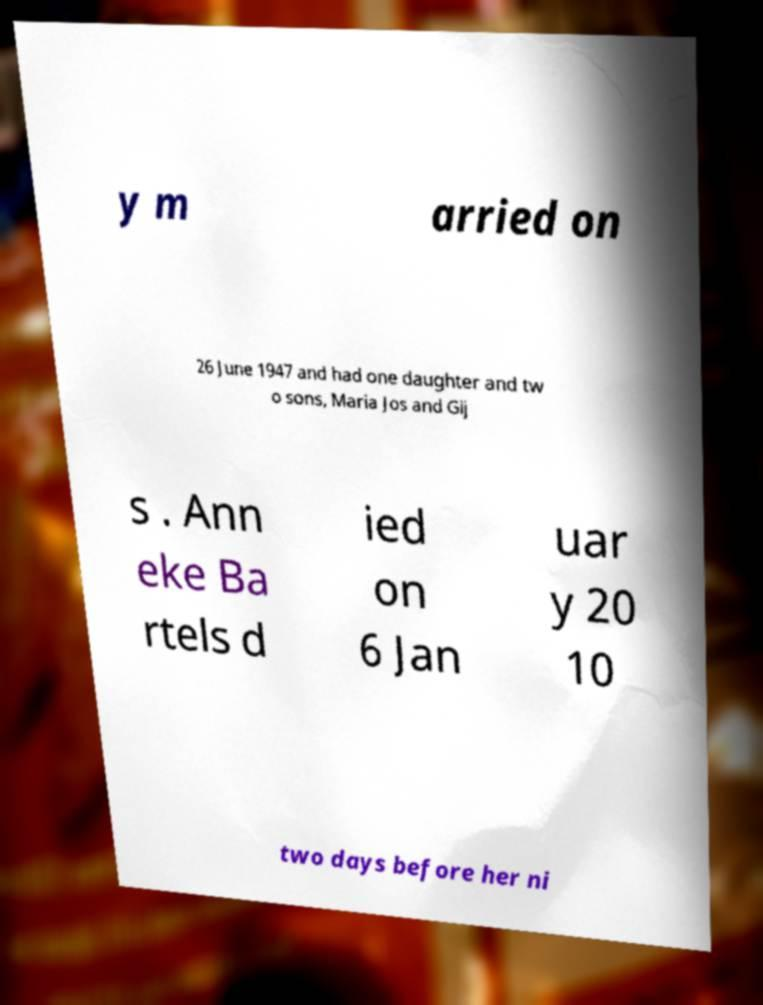Please read and relay the text visible in this image. What does it say? y m arried on 26 June 1947 and had one daughter and tw o sons, Maria Jos and Gij s . Ann eke Ba rtels d ied on 6 Jan uar y 20 10 two days before her ni 